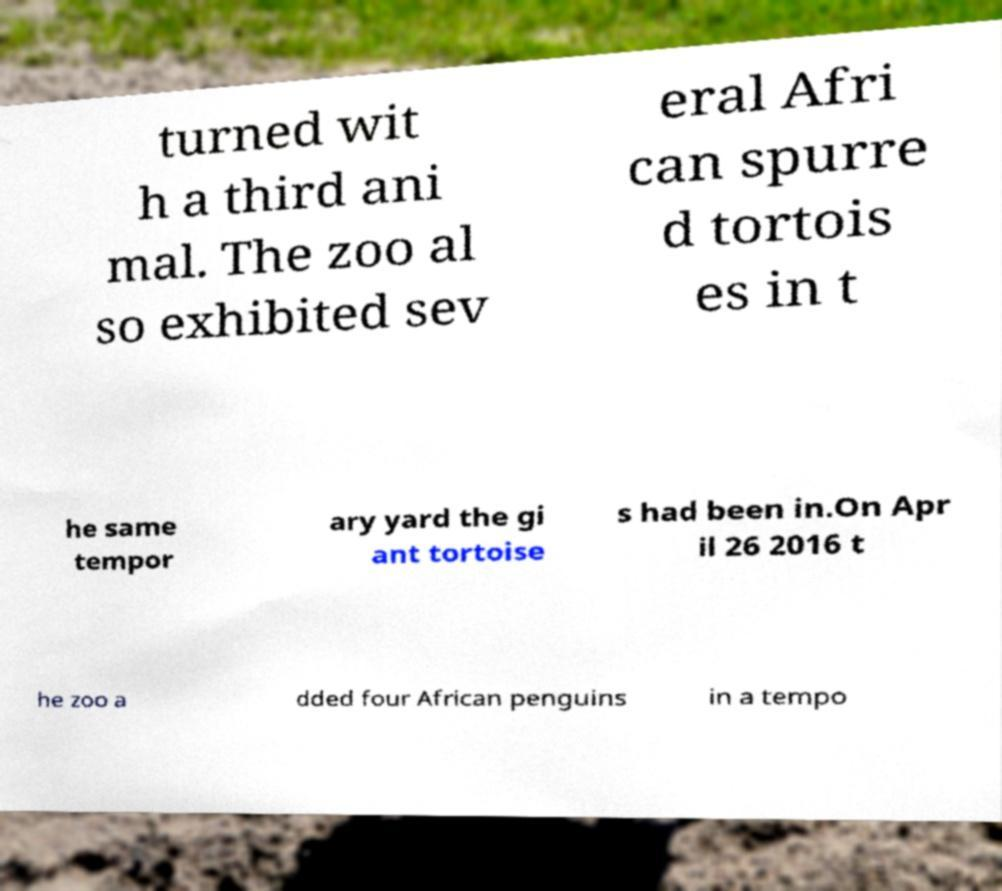Could you assist in decoding the text presented in this image and type it out clearly? turned wit h a third ani mal. The zoo al so exhibited sev eral Afri can spurre d tortois es in t he same tempor ary yard the gi ant tortoise s had been in.On Apr il 26 2016 t he zoo a dded four African penguins in a tempo 